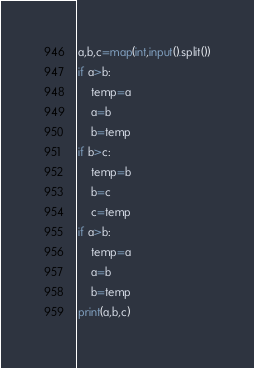Convert code to text. <code><loc_0><loc_0><loc_500><loc_500><_Python_>a,b,c=map(int,input().split())
if a>b:
    temp=a
    a=b
    b=temp
if b>c:
    temp=b
    b=c
    c=temp
if a>b:
    temp=a
    a=b
    b=temp
print(a,b,c)
</code> 